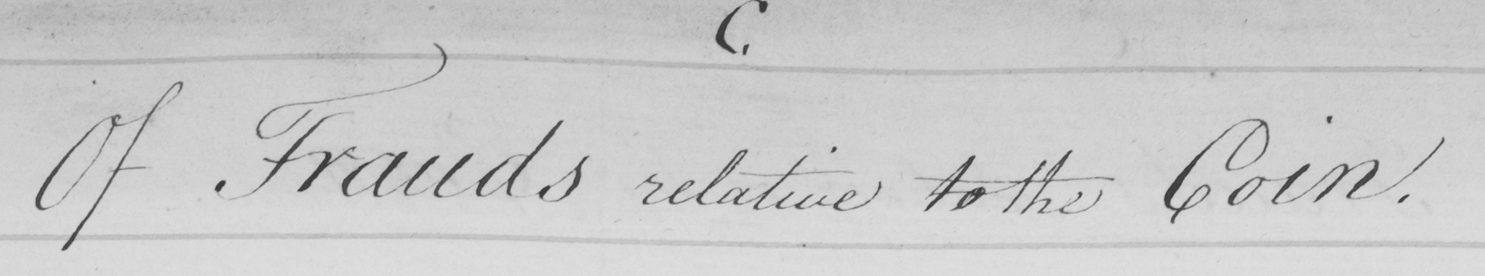Please transcribe the handwritten text in this image. Of Frauds relative to the Coin . 